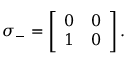Convert formula to latex. <formula><loc_0><loc_0><loc_500><loc_500>\sigma _ { - } = \left [ \begin{array} { l l } { 0 } & { 0 } \\ { 1 } & { 0 } \end{array} \right ] .</formula> 